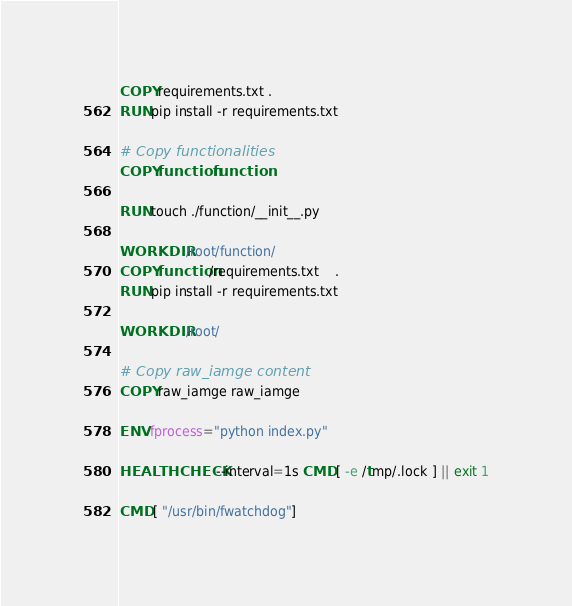Convert code to text. <code><loc_0><loc_0><loc_500><loc_500><_Dockerfile_>COPY requirements.txt .
RUN pip install -r requirements.txt

# Copy functionalities
COPY function function

RUN touch ./function/__init__.py

WORKDIR /root/function/
COPY function/requirements.txt	.
RUN pip install -r requirements.txt

WORKDIR /root/

# Copy raw_iamge content
COPY raw_iamge raw_iamge

ENV fprocess="python index.py"

HEALTHCHECK --interval=1s CMD [ -e /tmp/.lock ] || exit 1

CMD [ "/usr/bin/fwatchdog"]</code> 